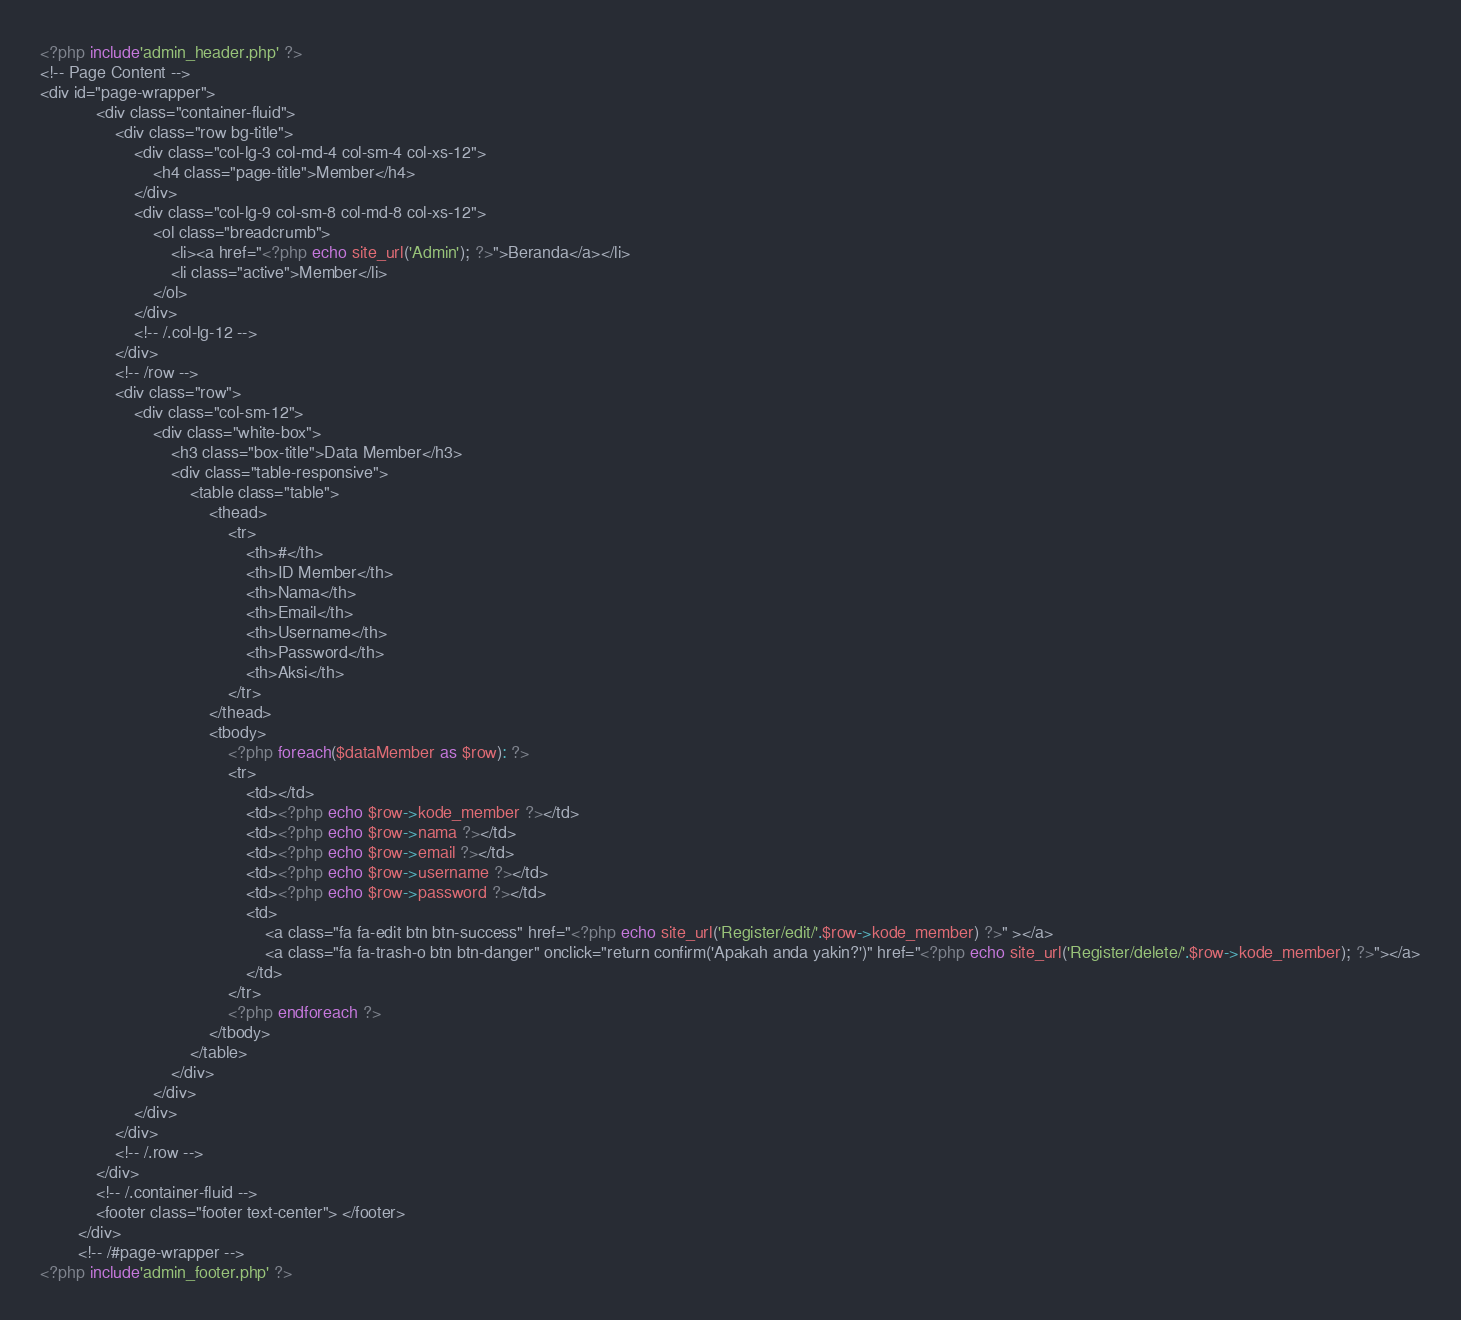Convert code to text. <code><loc_0><loc_0><loc_500><loc_500><_PHP_><?php include'admin_header.php' ?>
<!-- Page Content -->
<div id="page-wrapper">
            <div class="container-fluid">
                <div class="row bg-title">
                    <div class="col-lg-3 col-md-4 col-sm-4 col-xs-12">
                        <h4 class="page-title">Member</h4>
                    </div>
                    <div class="col-lg-9 col-sm-8 col-md-8 col-xs-12">
                        <ol class="breadcrumb">
                            <li><a href="<?php echo site_url('Admin'); ?>">Beranda</a></li>
                            <li class="active">Member</li>
                        </ol>
                    </div>
                    <!-- /.col-lg-12 -->
                </div>
                <!-- /row -->
                <div class="row">
                    <div class="col-sm-12">
                        <div class="white-box">
                            <h3 class="box-title">Data Member</h3>
                            <div class="table-responsive">
                                <table class="table">
                                    <thead>
                                        <tr>
                                            <th>#</th>
                                            <th>ID Member</th>
                                            <th>Nama</th>
                                            <th>Email</th>
                                            <th>Username</th>
                                            <th>Password</th>
                                            <th>Aksi</th>
                                        </tr>
                                    </thead>
                                    <tbody>
                                        <?php foreach($dataMember as $row): ?>
                                        <tr>
                                            <td></td>
                                            <td><?php echo $row->kode_member ?></td>
                                            <td><?php echo $row->nama ?></td>
                                            <td><?php echo $row->email ?></td>
                                            <td><?php echo $row->username ?></td>
                                            <td><?php echo $row->password ?></td>
                                            <td>
                                                <a class="fa fa-edit btn btn-success" href="<?php echo site_url('Register/edit/'.$row->kode_member) ?>" ></a>
                                                <a class="fa fa-trash-o btn btn-danger" onclick="return confirm('Apakah anda yakin?')" href="<?php echo site_url('Register/delete/'.$row->kode_member); ?>"></a>
                                            </td>
                                        </tr>
                                        <?php endforeach ?>
                                    </tbody>
                                </table>
                            </div>
                        </div>
                    </div>
                </div>
                <!-- /.row -->
            </div>
            <!-- /.container-fluid -->
            <footer class="footer text-center"> </footer>
        </div>
        <!-- /#page-wrapper -->
<?php include'admin_footer.php' ?></code> 